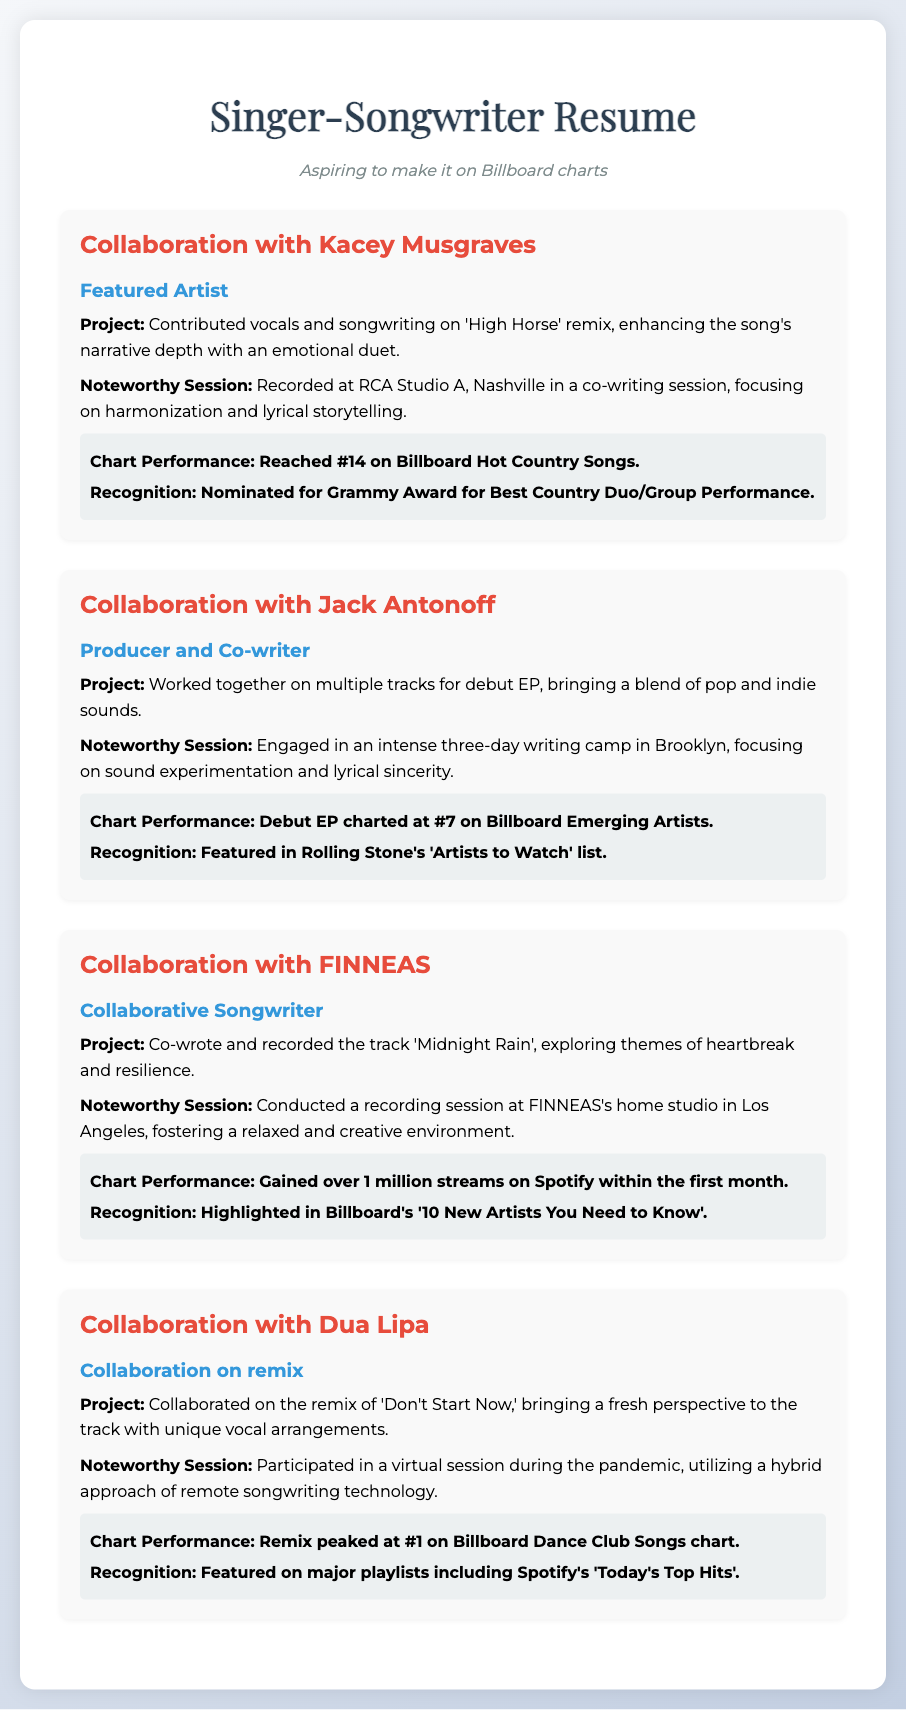what is the title of the project collaborated on with Kacey Musgraves? The title of the project is 'High Horse' remix, where the singer contributed vocals and songwriting.
Answer: 'High Horse' remix what was the chart performance of the collaboration with Jack Antonoff? The debut EP charted at #7 on Billboard Emerging Artists as a result of the collaboration.
Answer: #7 on Billboard Emerging Artists who was the featured artist in the collaboration with Dua Lipa? The collaboration with Dua Lipa involved a remix, which highlights her as the featured artist.
Answer: Dua Lipa how many streams did the track 'Midnight Rain' gain on Spotify within the first month? The document states that 'Midnight Rain' gained over 1 million streams on Spotify in the first month after release.
Answer: over 1 million streams what was the recognition for the collaboration with FINNEAS? The collaboration with FINNEAS led to being highlighted in Billboard's '10 New Artists You Need to Know'.
Answer: Billboard's '10 New Artists You Need to Know' what was unique about the session with Dua Lipa? The session with Dua Lipa during the pandemic utilized a hybrid approach of remote songwriting technology.
Answer: hybrid approach of remote songwriting technology how did the collaboration with Kacey Musgraves enhance the song? The collaboration enhanced the song's narrative depth with an emotional duet.
Answer: emotional duet what setting was used for the recording session with FINNEAS? The recording session with FINNEAS took place at his home studio in Los Angeles.
Answer: his home studio in Los Angeles what type of award was the collaboration with Kacey Musgraves nominated for? The collaboration was nominated for a Grammy Award, specifying the award type.
Answer: Grammy Award for Best Country Duo/Group Performance 